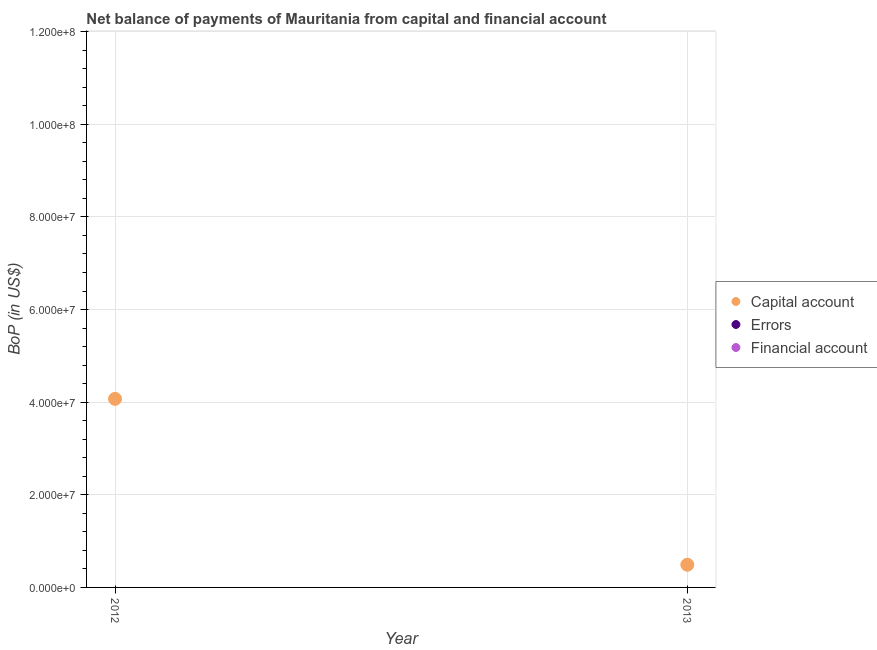Across all years, what is the maximum amount of net capital account?
Your answer should be very brief. 4.07e+07. Across all years, what is the minimum amount of financial account?
Your answer should be very brief. 0. In which year was the amount of net capital account maximum?
Your answer should be very brief. 2012. What is the total amount of net capital account in the graph?
Your answer should be very brief. 4.56e+07. What is the difference between the amount of net capital account in 2012 and that in 2013?
Your response must be concise. 3.58e+07. What is the difference between the amount of errors in 2012 and the amount of financial account in 2013?
Provide a succinct answer. 0. In how many years, is the amount of net capital account greater than the average amount of net capital account taken over all years?
Ensure brevity in your answer.  1. Is it the case that in every year, the sum of the amount of net capital account and amount of errors is greater than the amount of financial account?
Give a very brief answer. Yes. Does the amount of net capital account monotonically increase over the years?
Offer a terse response. No. Is the amount of financial account strictly greater than the amount of net capital account over the years?
Your response must be concise. No. Is the amount of net capital account strictly less than the amount of financial account over the years?
Your answer should be compact. No. How many years are there in the graph?
Your response must be concise. 2. Does the graph contain any zero values?
Provide a succinct answer. Yes. Where does the legend appear in the graph?
Offer a very short reply. Center right. How many legend labels are there?
Your response must be concise. 3. What is the title of the graph?
Offer a very short reply. Net balance of payments of Mauritania from capital and financial account. Does "Oil" appear as one of the legend labels in the graph?
Keep it short and to the point. No. What is the label or title of the Y-axis?
Ensure brevity in your answer.  BoP (in US$). What is the BoP (in US$) in Capital account in 2012?
Give a very brief answer. 4.07e+07. What is the BoP (in US$) in Capital account in 2013?
Make the answer very short. 4.90e+06. Across all years, what is the maximum BoP (in US$) of Capital account?
Offer a terse response. 4.07e+07. Across all years, what is the minimum BoP (in US$) in Capital account?
Ensure brevity in your answer.  4.90e+06. What is the total BoP (in US$) in Capital account in the graph?
Your answer should be compact. 4.56e+07. What is the total BoP (in US$) of Errors in the graph?
Provide a succinct answer. 0. What is the total BoP (in US$) of Financial account in the graph?
Provide a succinct answer. 0. What is the difference between the BoP (in US$) in Capital account in 2012 and that in 2013?
Your answer should be very brief. 3.58e+07. What is the average BoP (in US$) of Capital account per year?
Offer a terse response. 2.28e+07. What is the average BoP (in US$) of Errors per year?
Your answer should be very brief. 0. What is the ratio of the BoP (in US$) in Capital account in 2012 to that in 2013?
Make the answer very short. 8.31. What is the difference between the highest and the second highest BoP (in US$) of Capital account?
Make the answer very short. 3.58e+07. What is the difference between the highest and the lowest BoP (in US$) of Capital account?
Make the answer very short. 3.58e+07. 